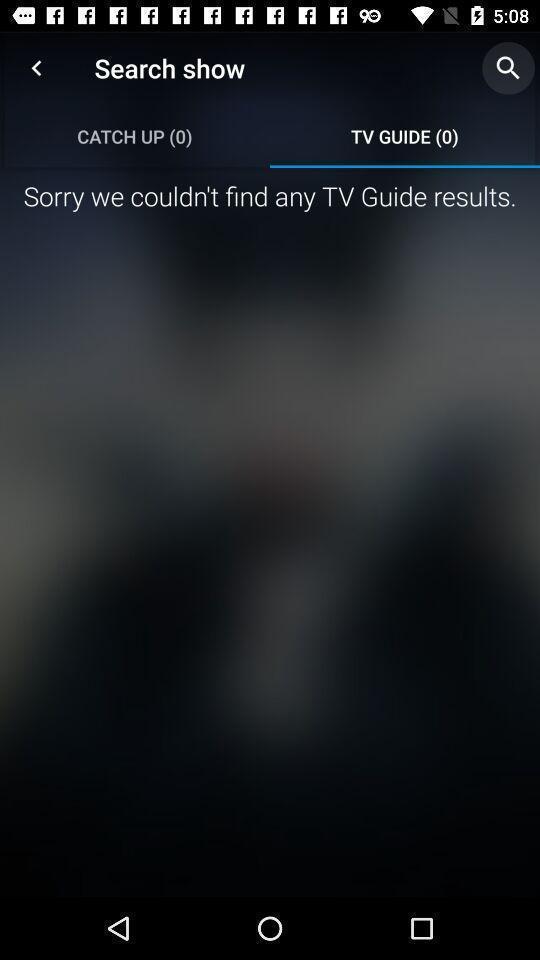Give me a narrative description of this picture. Screen displaying the tv guide page which has no result. 